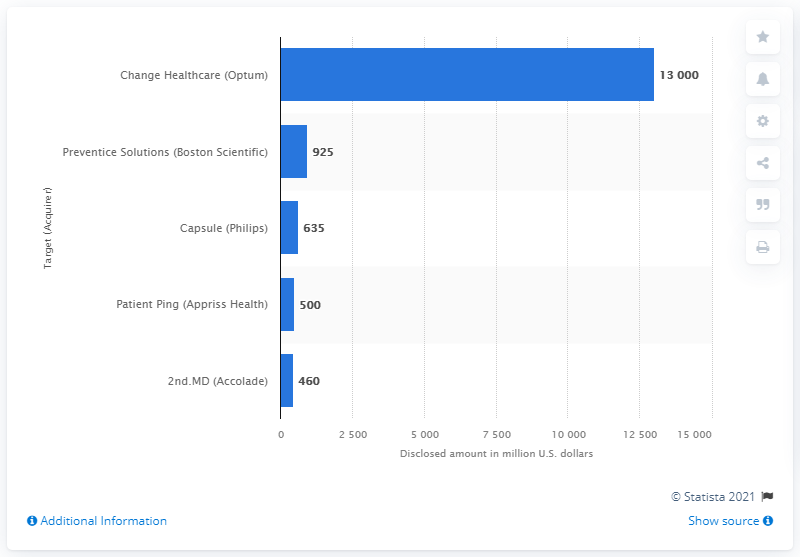Draw attention to some important aspects in this diagram. The acquisition of Change Healthcare by Optum was valued at 13000. 